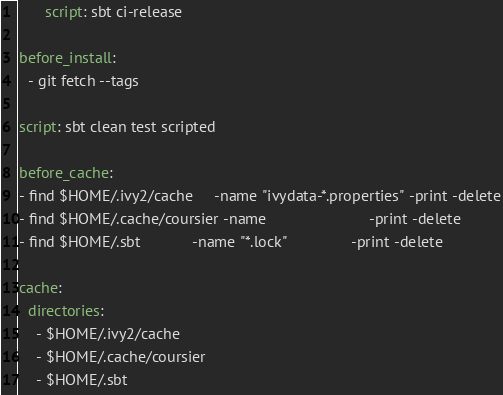<code> <loc_0><loc_0><loc_500><loc_500><_YAML_>      script: sbt ci-release

before_install:
  - git fetch --tags

script: sbt clean test scripted

before_cache:
- find $HOME/.ivy2/cache     -name "ivydata-*.properties" -print -delete
- find $HOME/.cache/coursier -name                        -print -delete
- find $HOME/.sbt            -name "*.lock"               -print -delete

cache:
  directories:
    - $HOME/.ivy2/cache
    - $HOME/.cache/coursier
    - $HOME/.sbt
</code> 